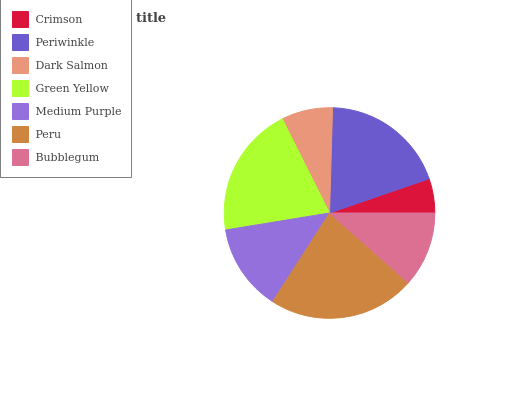Is Crimson the minimum?
Answer yes or no. Yes. Is Peru the maximum?
Answer yes or no. Yes. Is Periwinkle the minimum?
Answer yes or no. No. Is Periwinkle the maximum?
Answer yes or no. No. Is Periwinkle greater than Crimson?
Answer yes or no. Yes. Is Crimson less than Periwinkle?
Answer yes or no. Yes. Is Crimson greater than Periwinkle?
Answer yes or no. No. Is Periwinkle less than Crimson?
Answer yes or no. No. Is Medium Purple the high median?
Answer yes or no. Yes. Is Medium Purple the low median?
Answer yes or no. Yes. Is Bubblegum the high median?
Answer yes or no. No. Is Peru the low median?
Answer yes or no. No. 